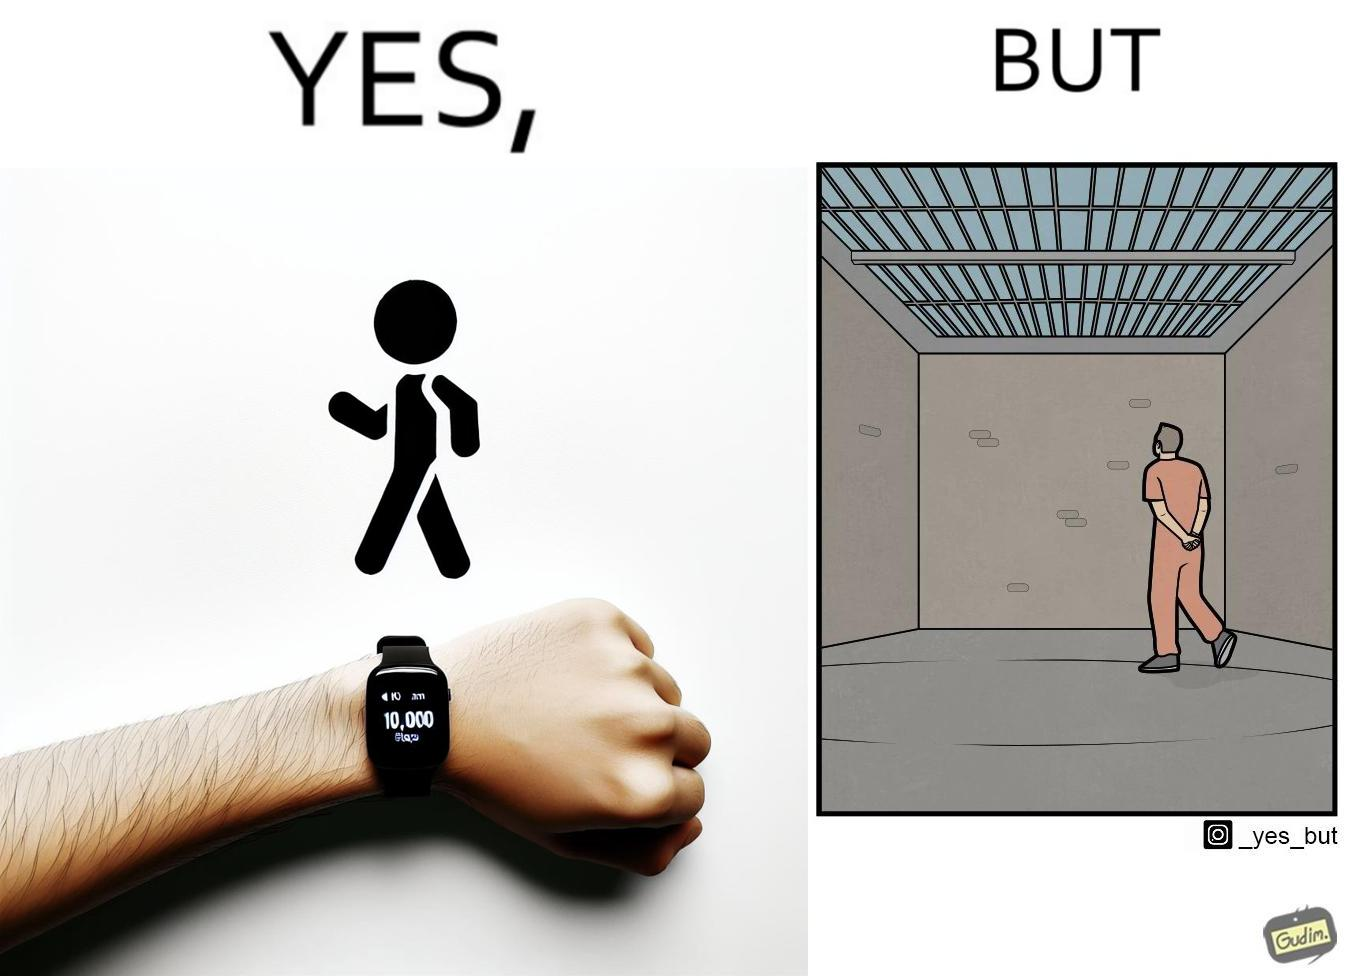Describe what you see in the left and right parts of this image. In the left part of the image: a smartwatch on a person's wrist showing 10,000 steps completed, indicating that a goal has been reached. In the right part of the image: a person walking in orange clothes, who is apparently a prisoner inside a jail. 